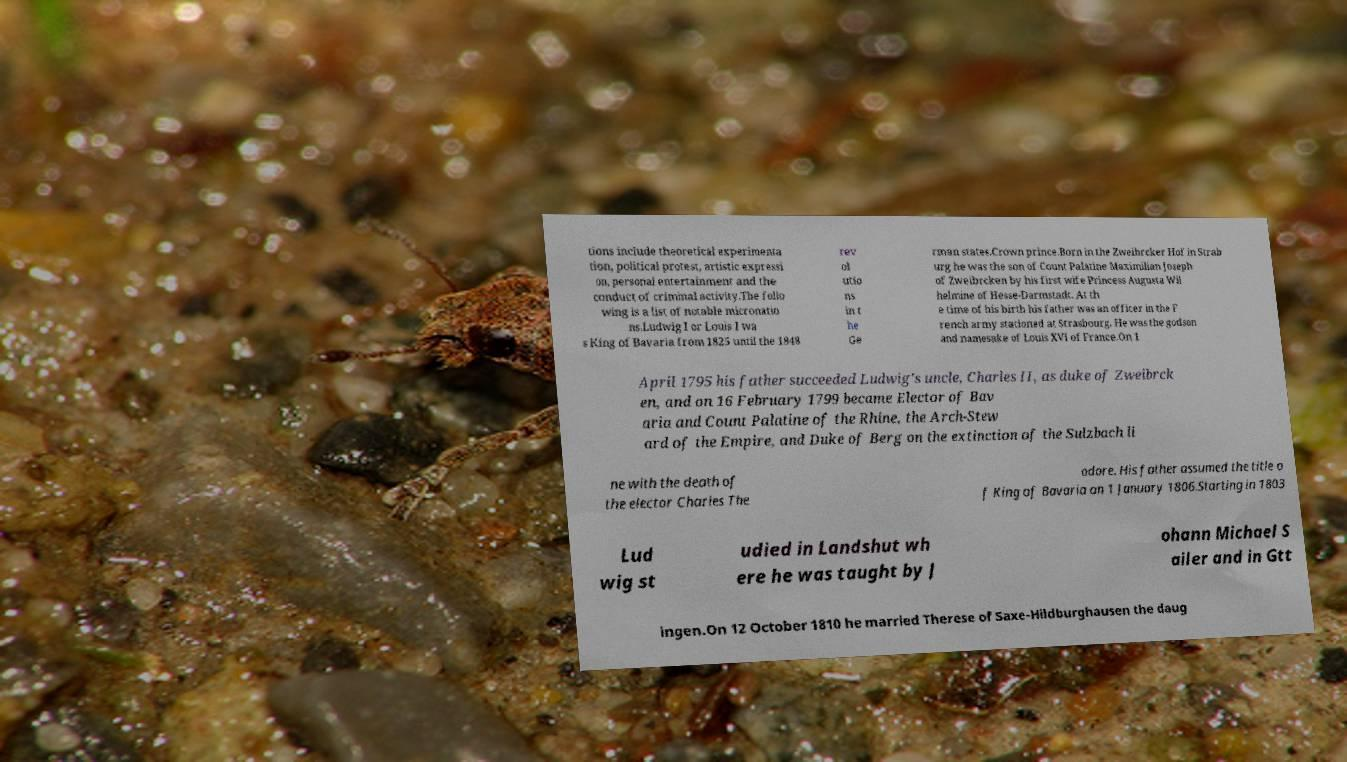There's text embedded in this image that I need extracted. Can you transcribe it verbatim? tions include theoretical experimenta tion, political protest, artistic expressi on, personal entertainment and the conduct of criminal activity.The follo wing is a list of notable micronatio ns.Ludwig I or Louis I wa s King of Bavaria from 1825 until the 1848 rev ol utio ns in t he Ge rman states.Crown prince.Born in the Zweibrcker Hof in Strab urg he was the son of Count Palatine Maximilian Joseph of Zweibrcken by his first wife Princess Augusta Wil helmine of Hesse-Darmstadt. At th e time of his birth his father was an officer in the F rench army stationed at Strasbourg. He was the godson and namesake of Louis XVI of France.On 1 April 1795 his father succeeded Ludwig's uncle, Charles II, as duke of Zweibrck en, and on 16 February 1799 became Elector of Bav aria and Count Palatine of the Rhine, the Arch-Stew ard of the Empire, and Duke of Berg on the extinction of the Sulzbach li ne with the death of the elector Charles The odore. His father assumed the title o f King of Bavaria on 1 January 1806.Starting in 1803 Lud wig st udied in Landshut wh ere he was taught by J ohann Michael S ailer and in Gtt ingen.On 12 October 1810 he married Therese of Saxe-Hildburghausen the daug 